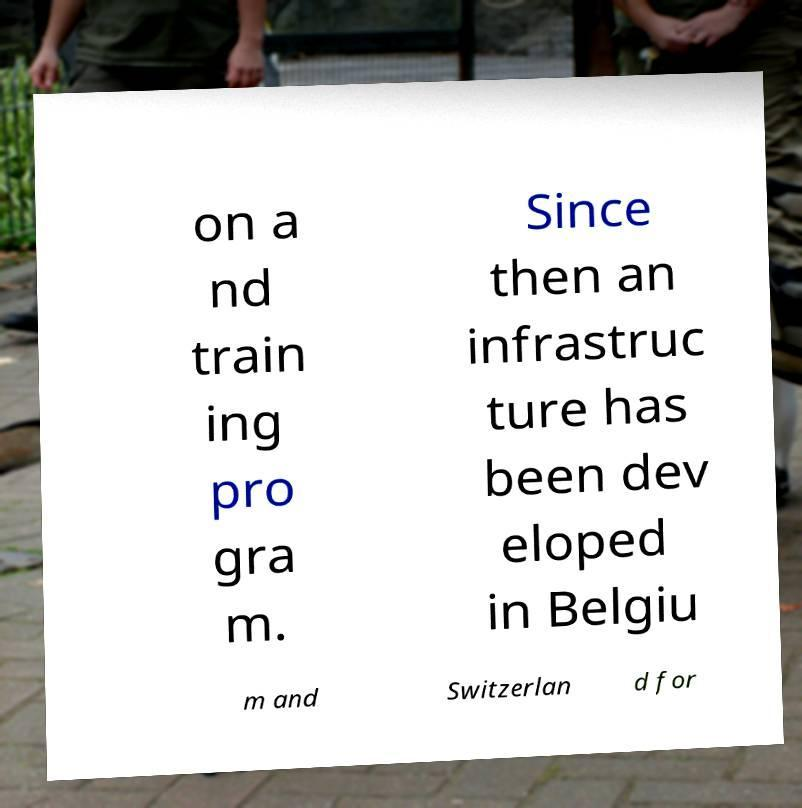Can you read and provide the text displayed in the image?This photo seems to have some interesting text. Can you extract and type it out for me? on a nd train ing pro gra m. Since then an infrastruc ture has been dev eloped in Belgiu m and Switzerlan d for 